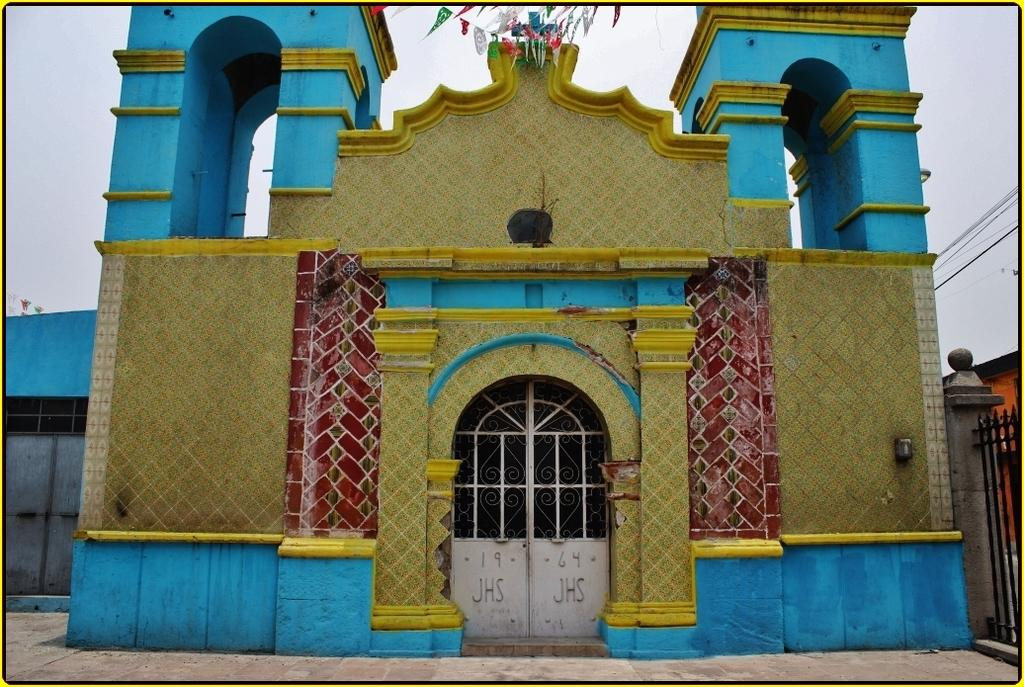What type of structure is present in the image? There is a house in the image. How is the house decorated? The house is painted with different colors. What can be seen at the top of the image? There are flags at the top of the image. Where is the entrance to the house located in the image? There is a gate in the bottom right corner of the image. What type of spoon is being used to take a bite of the house in the image? There is no spoon or bite present in the image; it features a house with a gate and flags. 